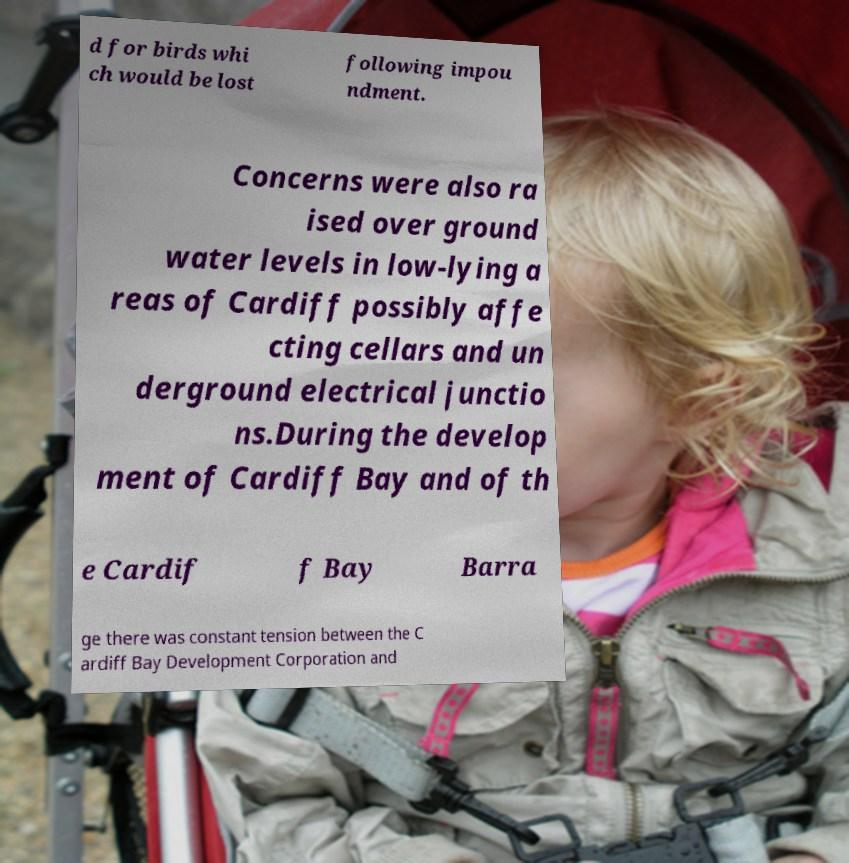For documentation purposes, I need the text within this image transcribed. Could you provide that? d for birds whi ch would be lost following impou ndment. Concerns were also ra ised over ground water levels in low-lying a reas of Cardiff possibly affe cting cellars and un derground electrical junctio ns.During the develop ment of Cardiff Bay and of th e Cardif f Bay Barra ge there was constant tension between the C ardiff Bay Development Corporation and 